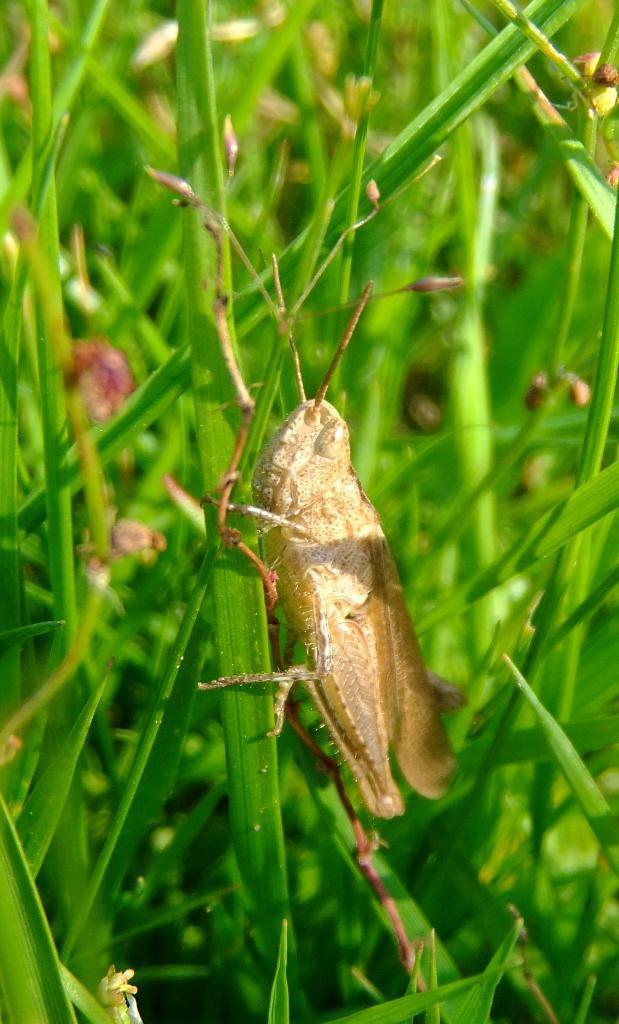Describe this image in one or two sentences. In the image there is grasshopper standing on the grass. 